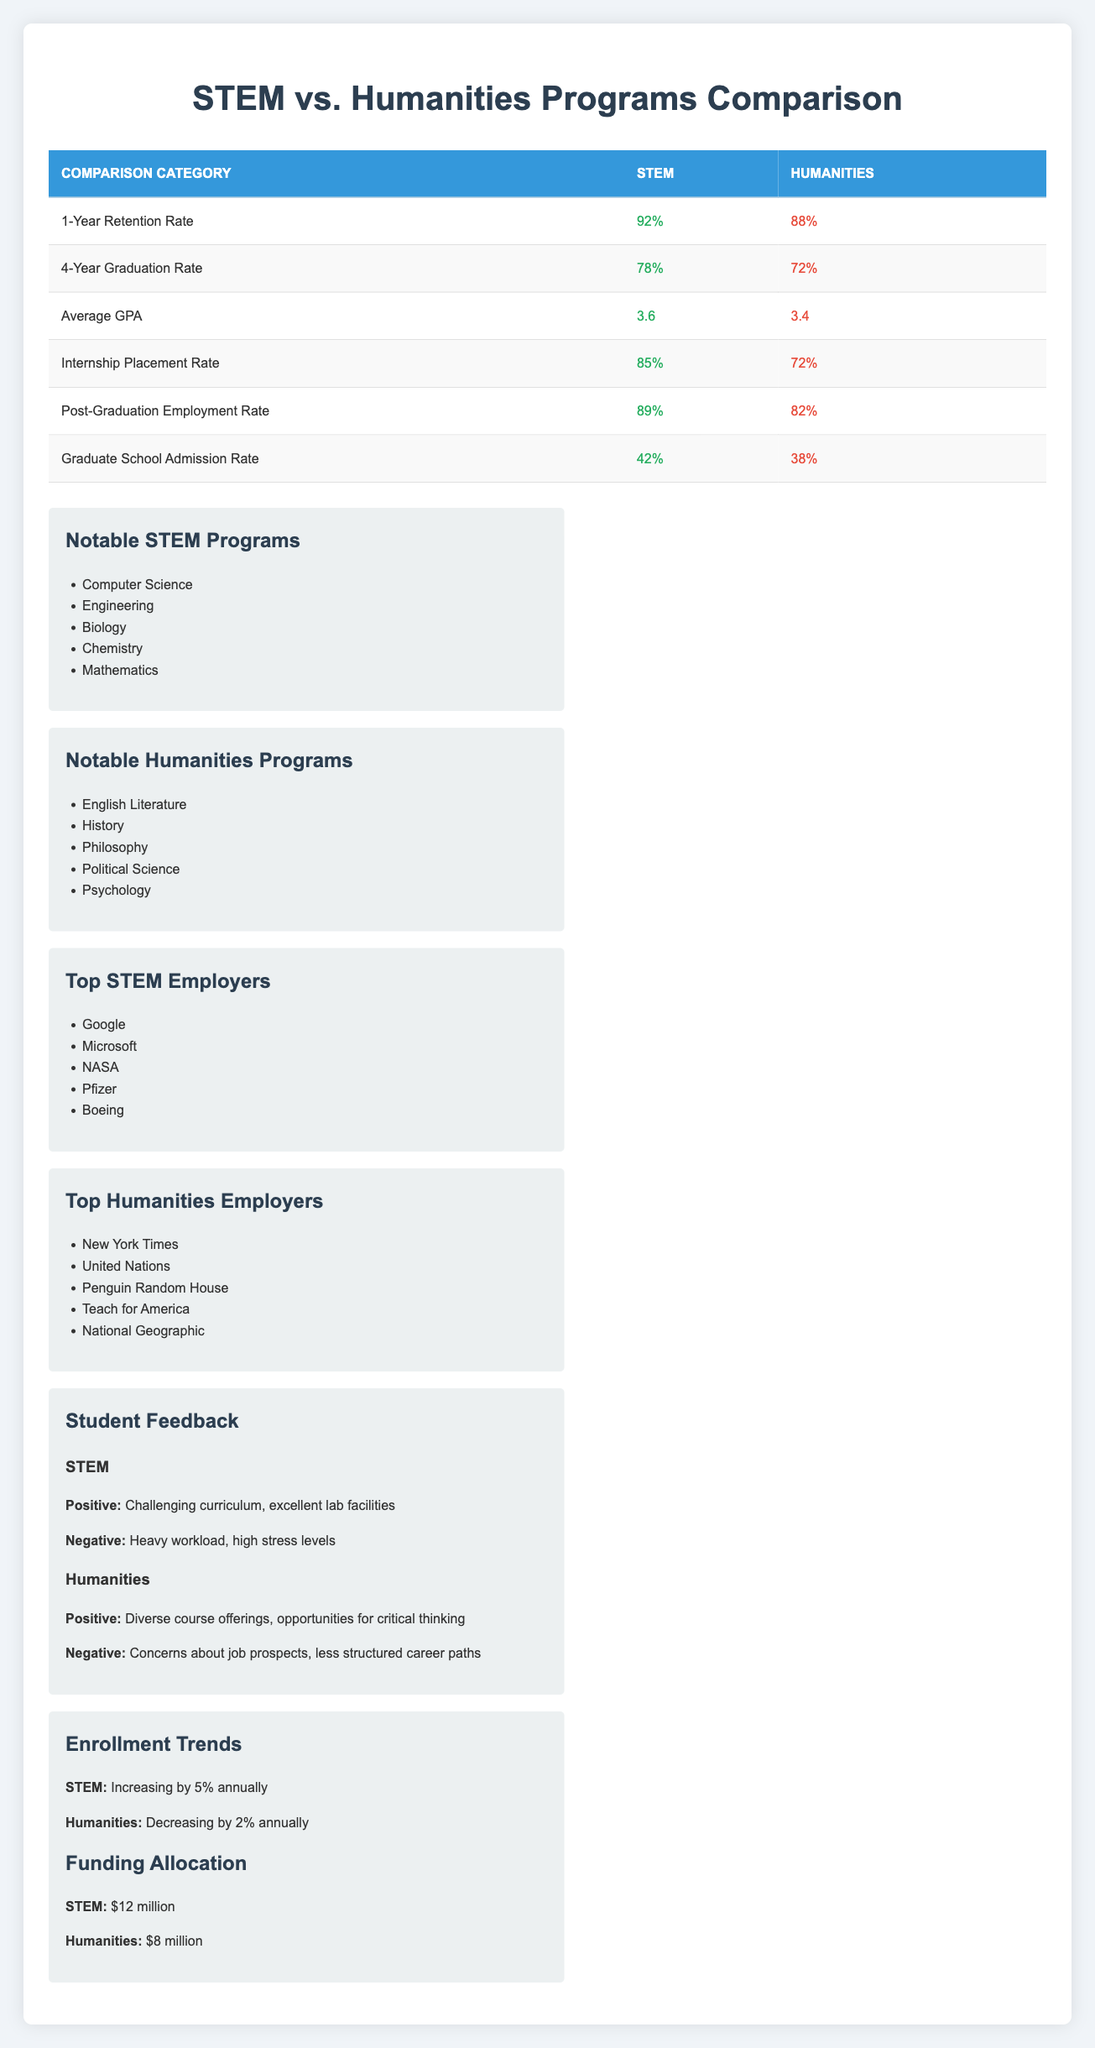What is the 1-Year Retention Rate for STEM programs? The table lists the retention rates for both program types in the "1-Year Retention Rate" row. For STEM, it shows "92%".
Answer: 92% Which program type has a higher Average GPA? By comparing the "Average GPA" row, STEM shows "3.6" while Humanities shows "3.4". Since 3.6 is greater than 3.4, STEM has a higher average GPA.
Answer: STEM What is the difference in the Post-Graduation Employment Rate between STEM and Humanities? The table provides the Post-Graduation Employment Rates as "89%" for STEM and "82%" for Humanities. The difference can be calculated: 89% - 82% = 7%.
Answer: 7% True or False: The 4-Year Graduation Rate for Humanities is higher than that for STEM. The table shows the 4-Year Graduation Rates as "72%" for Humanities and "78%" for STEM. Since 72% is less than 78%, the statement is false.
Answer: False If a student enrolled in a STEM program, what is the likelihood (percentage) of them securing an internship based on the placement rate? The table indicates an "Internship Placement Rate" of "85%" for STEM programs. This means there is an 85% likelihood of securing an internship.
Answer: 85% How do the Graduate School Admission Rates for STEM and Humanities compare? The table shows "42%" for STEM and "38%" for Humanities in the "Graduate School Admission Rate" row. Since 42% is greater than 38%, STEM has a higher admission rate.
Answer: STEM What percentage of students in Humanities programs are likely to secure internships? The table specifies the Internship Placement Rate for Humanities as "72%". This indicates that 72% of Humanities students are likely to secure internships.
Answer: 72% Based on the table, which program type has a lower funding allocation? Comparing the "Funding Allocation" values, STEM has "$12 million" while Humanities has "$8 million". Since $8 million is less than $12 million, Humanities has a lower funding allocation.
Answer: Humanities Calculate the average retention rate for both program types. The 1-Year Retention Rate for STEM is "92%" and for Humanities is "88%". The average retention rate is calculated as (92% + 88%) / 2 = 90%.
Answer: 90% 